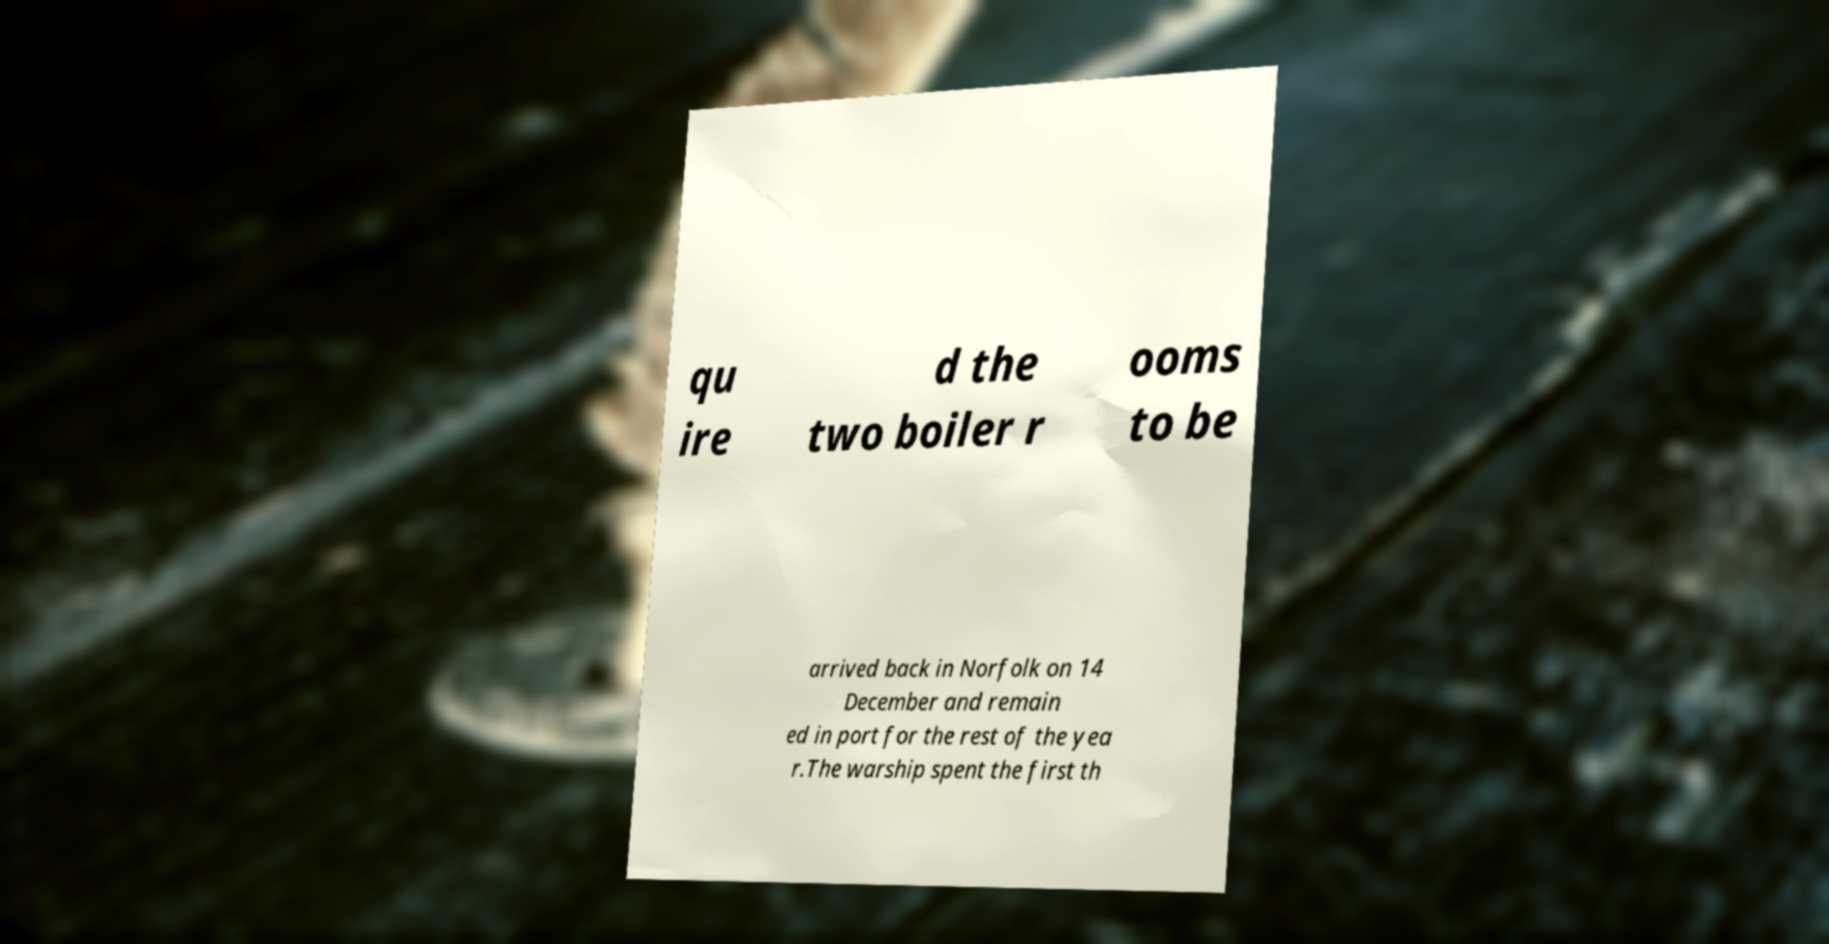I need the written content from this picture converted into text. Can you do that? qu ire d the two boiler r ooms to be arrived back in Norfolk on 14 December and remain ed in port for the rest of the yea r.The warship spent the first th 